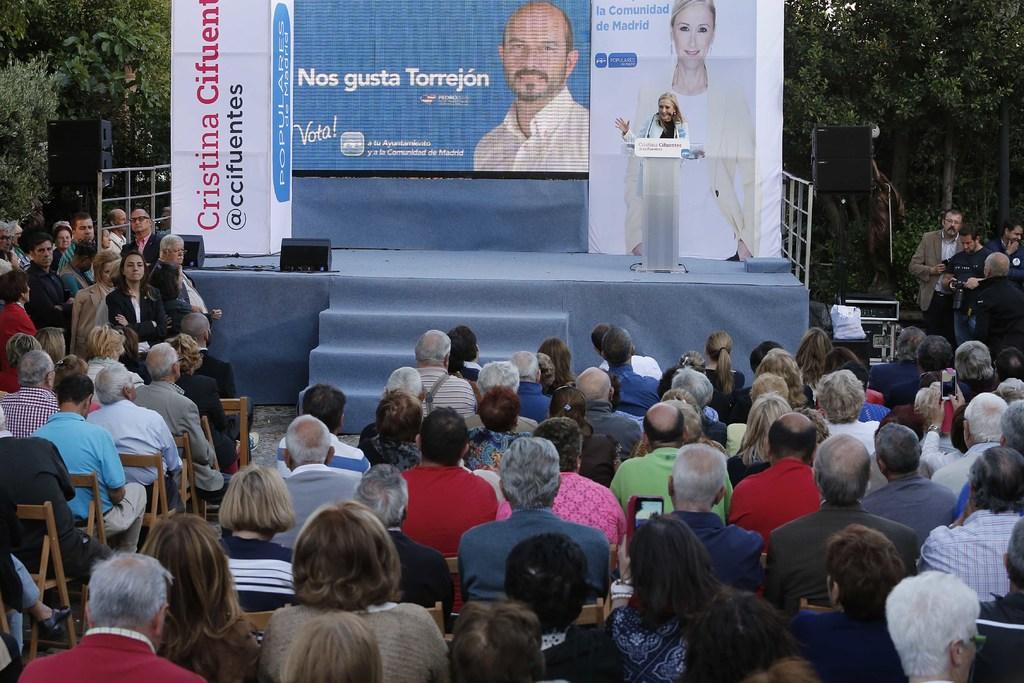Can you describe this image briefly? In this picture I can observe some people sitting in the chairs. There are men and women in this picture. There is a woman standing on the stage in front of a podium. We can observe a poster in the background. I can observe speakers on either sides of the stage. In the background there are trees. 